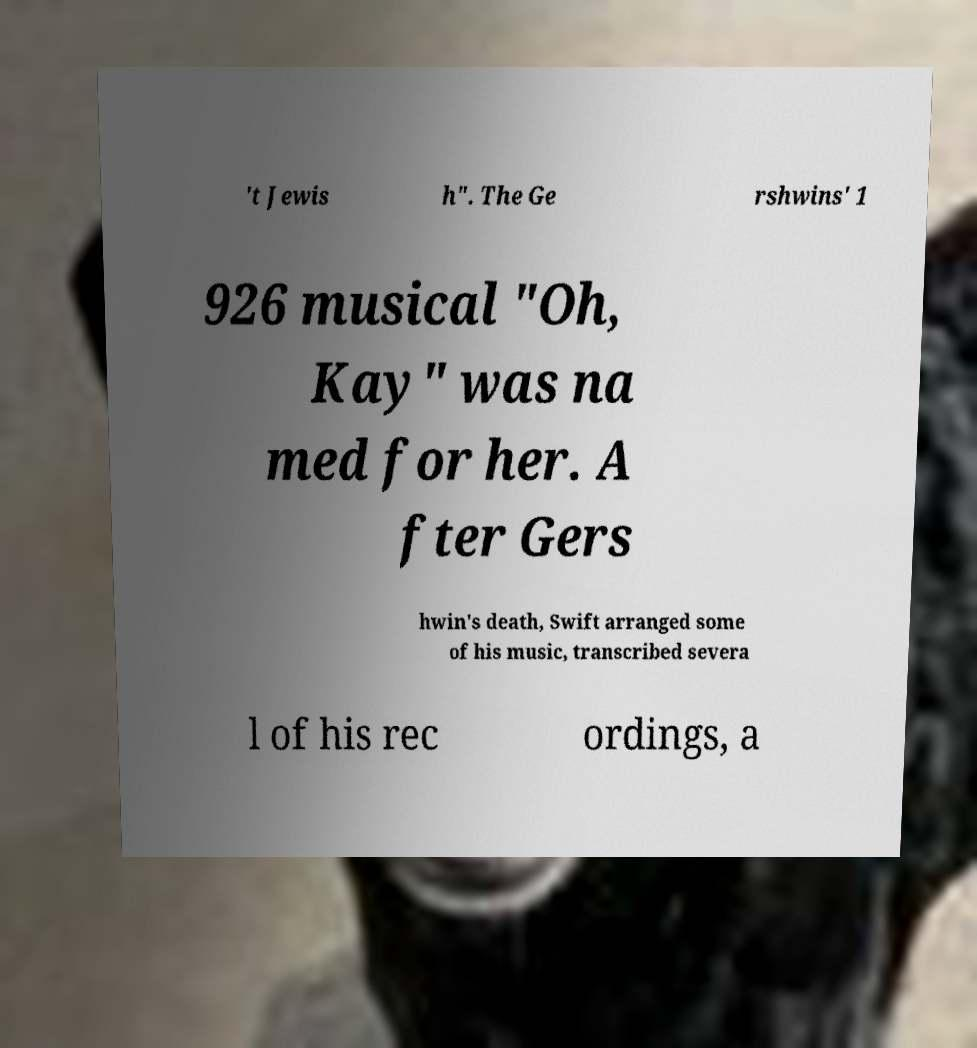Could you assist in decoding the text presented in this image and type it out clearly? 't Jewis h". The Ge rshwins' 1 926 musical "Oh, Kay" was na med for her. A fter Gers hwin's death, Swift arranged some of his music, transcribed severa l of his rec ordings, a 